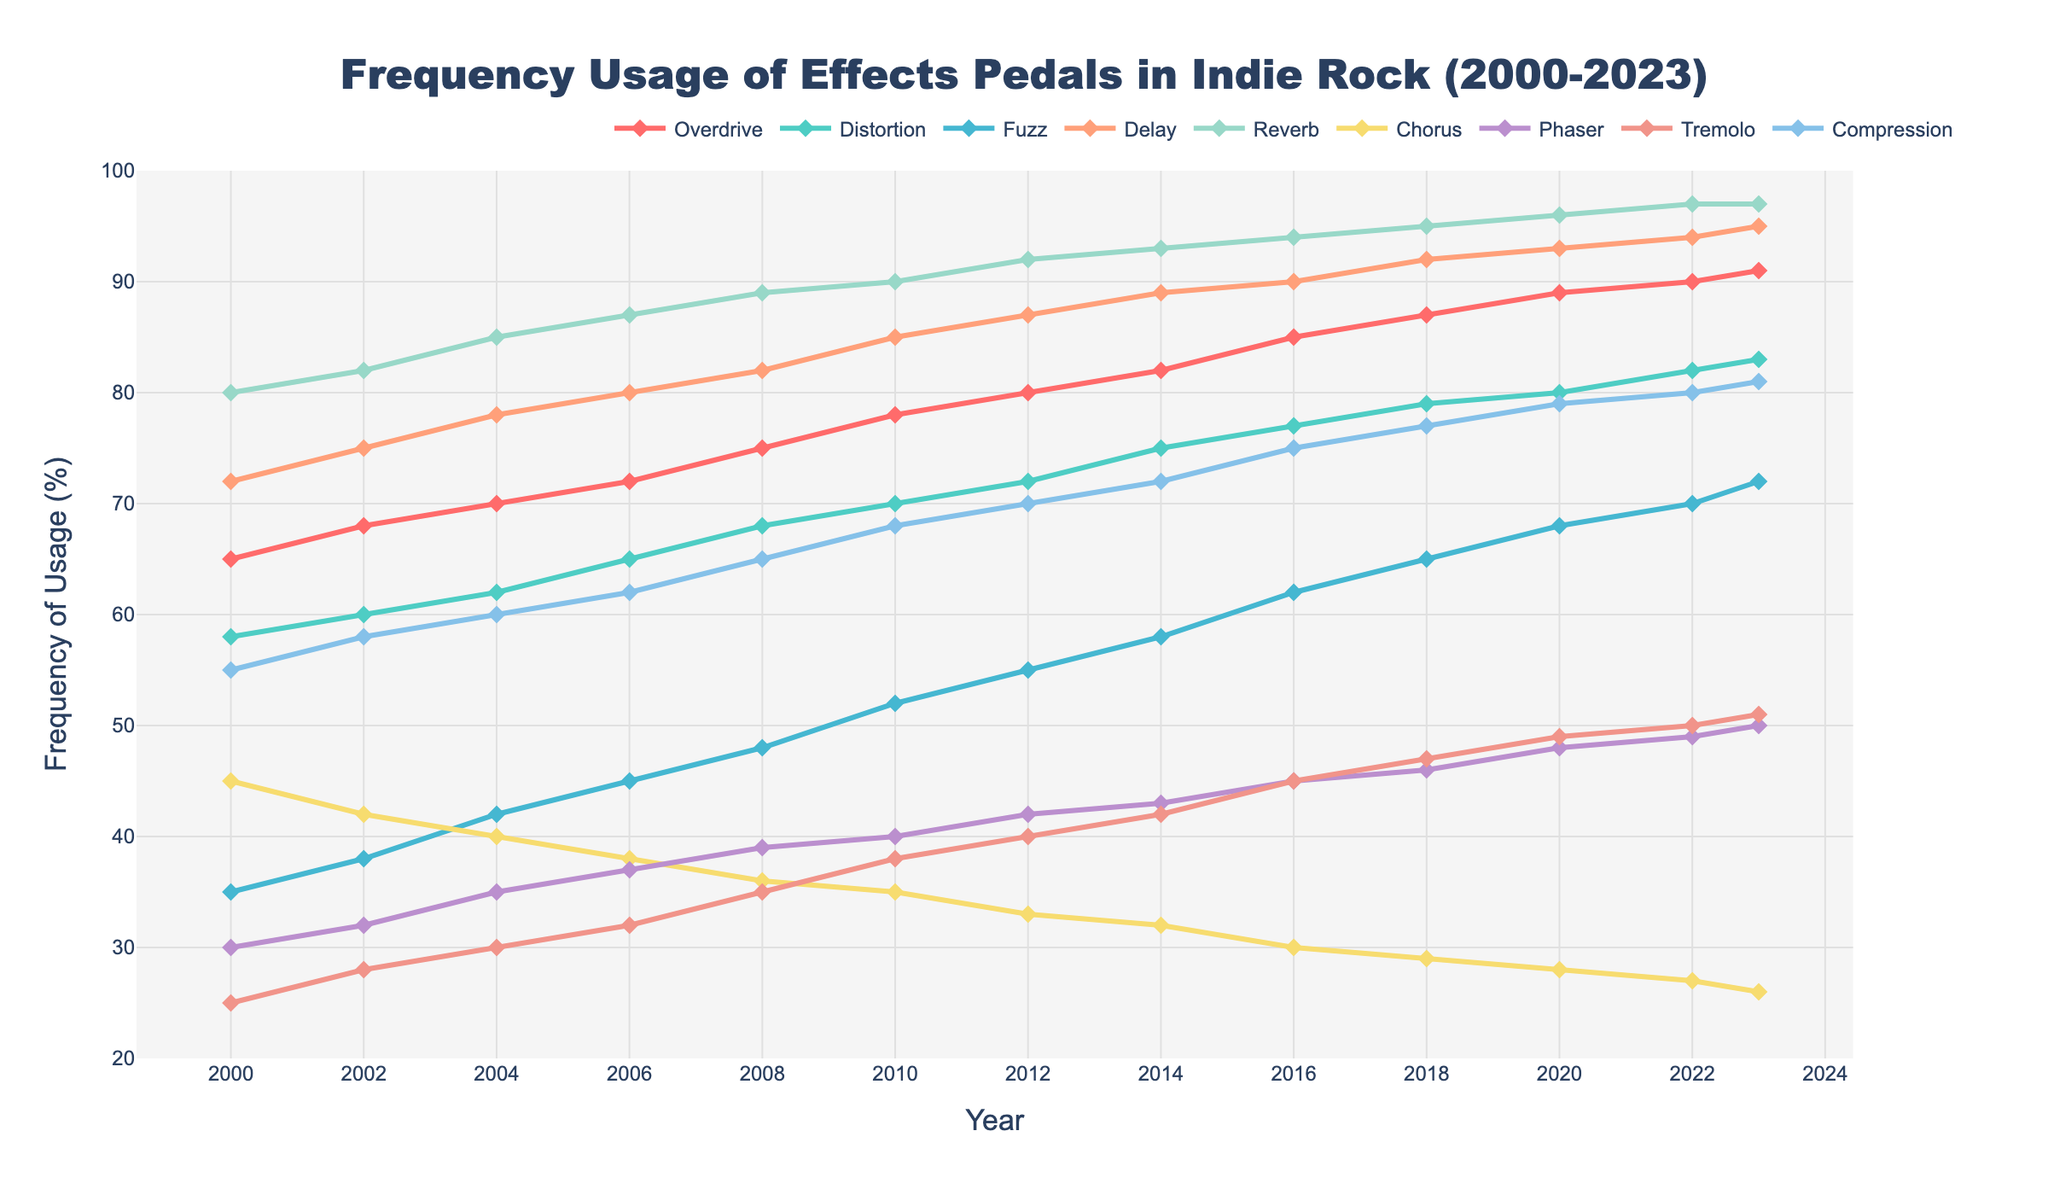What's the overall trend of the Overdrive effect from 2000 to 2023? The line representing Overdrive shows a consistent increase over the years, starting at 65 in 2000 and rising to 91 in 2023. This indicates a steady upward trend in the usage of the Overdrive effect in indie rock.
Answer: Steady increase Which effect had the highest frequency of usage in 2023? In 2023, the Reverb effect has the highest frequency of usage, reaching 97%. This is visually represented by the line for Reverb being the highest among all other effects.
Answer: Reverb Compare the frequency of usage of Delay and Chorus in 2010. Which one was more frequently used and by how much? In 2010, Delay had a frequency of 85%, while Chorus had a frequency of 35%. The difference in their usage is 85 - 35 = 50%. Therefore, Delay was used 50% more than Chorus.
Answer: Delay by 50% How did the usage of the Fuzz effect change from 2000 to 2023? The Fuzz effect started at 35% in 2000 and gradually increased to 72% by 2023. This shows a positive trend in the usage of the Fuzz effect over the years.
Answer: Increased What's the average frequency usage of Compression between 2000 and 2023? To find the average, sum the frequency values of Compression for each year and divide by the number of data points. Summing up (55 + 58 + 60 + 62 + 65 + 68 + 70 + 72 + 75 + 77 + 79 + 80 + 81) = 902. There are 13 data points, so the average is 902 / 13 ≈ 69.38%.
Answer: 69.38% In which year did the Phaser effect surpass the 45% frequency usage mark? The line for the Phaser effect surpasses the 45% frequency mark for the first time in 2016, where it reaches 45%.
Answer: 2016 Which effect experienced the steepest increase between 2000 and 2010? By comparing the gradients of all the lines, Fuzz experienced the steepest increase, rising from 35% in 2000 to 52% in 2010, a difference of 17% over 10 years.
Answer: Fuzz Is there an effect whose usage decreased over the years? The usage of the Chorus effect shows a downward trend, starting at 45% in 2000 and decreasing to 26% in 2023.
Answer: Chorus How close in frequency were the Overdrive and Distortion effects in 2023? In 2023, the Overdrive effect had a frequency of 91%, while the Distortion effect had a frequency of 83%. The difference is 91 - 83 = 8%.
Answer: 8% 